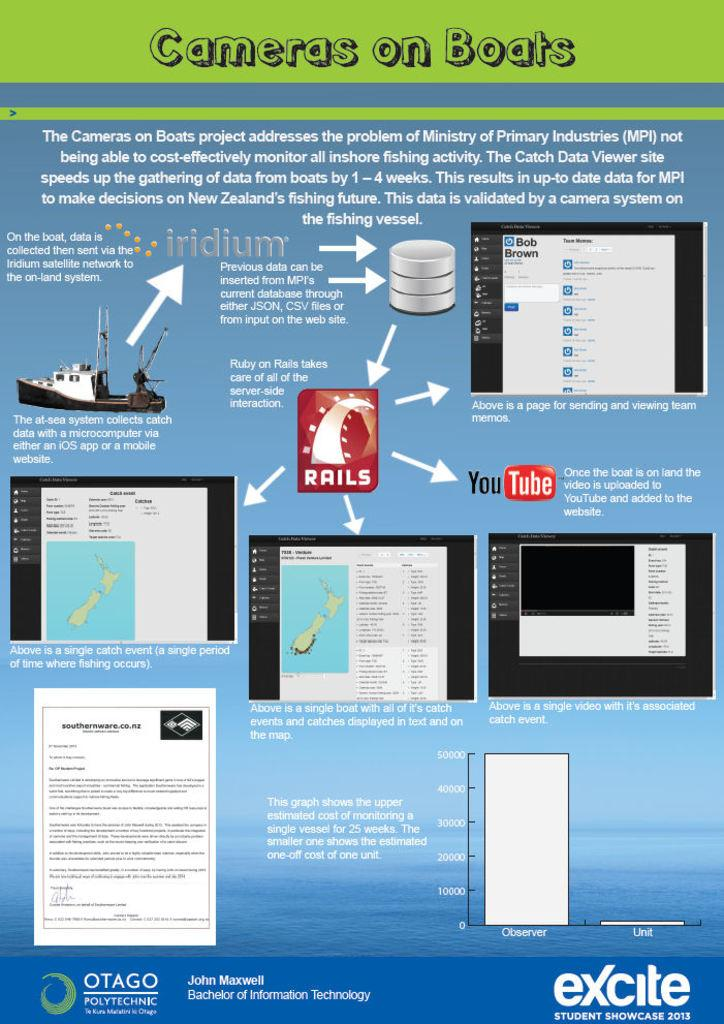What is present on the poster in the image? The poster contains text and images. Can you describe the content of the poster? The poster contains text and images, but the specific content cannot be determined from the provided facts. Reasoning: Let's think step by step by step in order to produce the conversation. We start by identifying the main subject in the image, which is the poster. Then, we describe the general characteristics of the poster, mentioning that it contains both text and images. We avoid making assumptions about the specific content of the poster, as it is not mentioned in the provided facts. Absurd Question/Answer: What type of polish is being applied to the poster in the image? There is no mention of polish or any application process in the image, so it cannot be determined from the provided facts. What direction is the wind blowing in the image? There is no mention of wind or any weather conditions in the image, so it cannot be determined from the provided facts. 